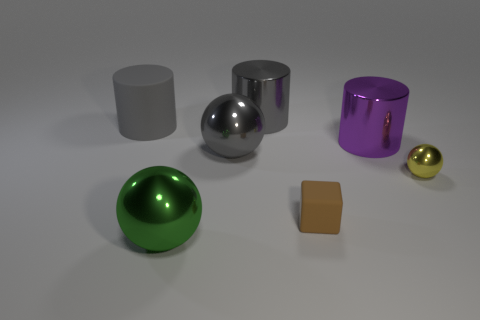There is a matte object that is left of the gray object that is behind the big rubber cylinder; what is its shape?
Make the answer very short. Cylinder. Is the color of the metal sphere to the right of the tiny brown rubber cube the same as the rubber block?
Make the answer very short. No. There is a sphere that is both to the left of the tiny brown matte cube and right of the green metallic thing; what color is it?
Offer a terse response. Gray. Is there a tiny yellow thing that has the same material as the purple object?
Make the answer very short. Yes. The brown matte object is what size?
Your response must be concise. Small. What is the size of the metal ball to the right of the big metal sphere that is behind the yellow shiny thing?
Offer a very short reply. Small. What material is the green object that is the same shape as the yellow thing?
Keep it short and to the point. Metal. What number of gray objects are there?
Your answer should be very brief. 3. There is a metallic object that is left of the gray shiny thing that is in front of the big cylinder that is to the right of the matte cube; what color is it?
Offer a terse response. Green. Is the number of big green matte cylinders less than the number of spheres?
Ensure brevity in your answer.  Yes. 